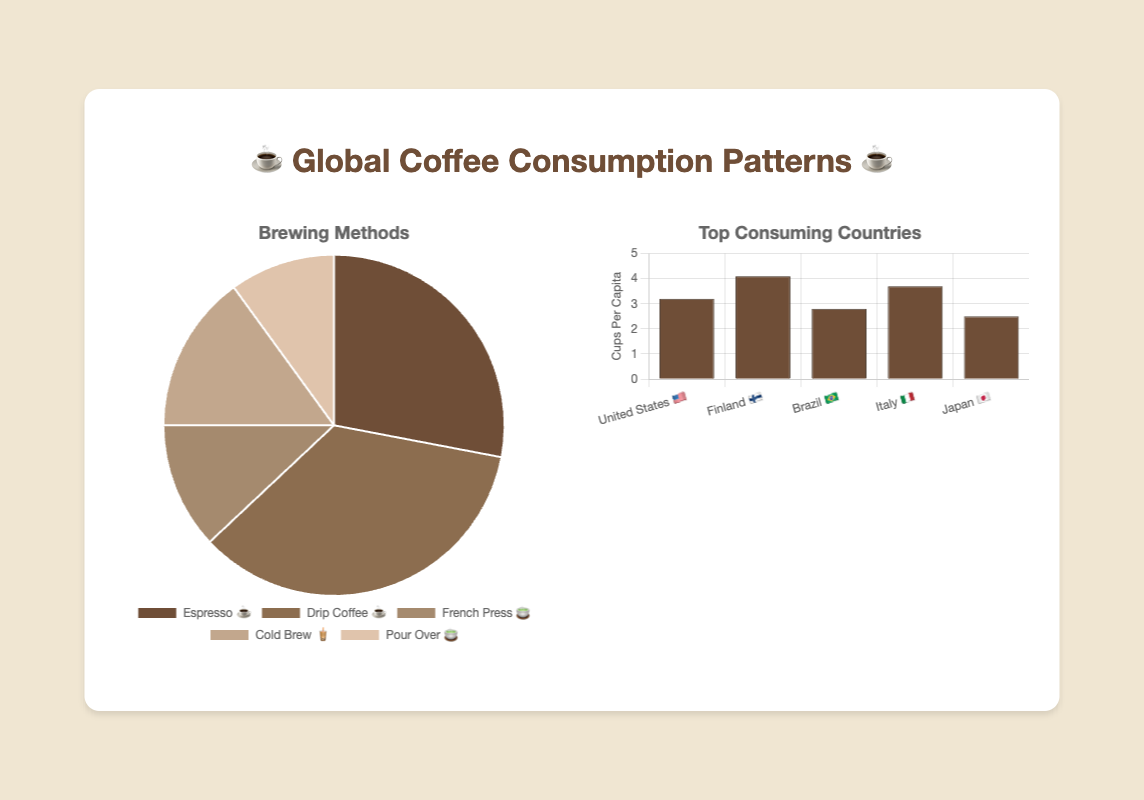What percentage of global coffee consumption is attributed to Drip Coffee ☕? The pie chart shows that Drip Coffee ☕ has a percentage listed within the chart segments. By looking at the label for Drip Coffee ☕, we see it reads 35%
Answer: 35% Which brewing method has the smallest percentage of global coffee consumption? By observing the pie chart, we can compare the listed percentages for each brewing method. The smallest segment by visual size is the one labeled "Pour Over 🍵" with a percentage of 10%
Answer: Pour Over 🍵 How many cups per capita does Italy 🇮🇹 consume, according to the bar chart? The bar chart on the right shows the countries on the x-axis and the corresponding cups per capita on the y-axis. For Italy 🇮🇹, the bar height corresponds to 3.7 cups per capita
Answer: 3.7 Which country has the highest cups per capita consumption? By comparing the heights of the bars in the chart, we see that Finland 🇫🇮 has the highest bar, which corresponds to 4.1 cups per capita
Answer: Finland 🇫🇮 What's the total percentage of global coffee consumption for French Press 🍵 and Cold Brew 🧋 methods combined? The pie chart lists percentages for each brewing method. Adding the percentages for French Press 🍵 (12%) and Cold Brew 🧋 (15%) gives a combined total of 12 + 15 = 27%
Answer: 27% Compare the coffee consumption per capita between the United States 🇺🇸 and Japan 🇯🇵. Which country consumes more and by how much more? The bar chart shows the cups per capita for the United States 🇺🇸 at 3.2 and Japan 🇯🇵 at 2.5. The difference is 3.2 - 2.5 = 0.7 cups. Therefore, the United States 🇺🇸 consumes 0.7 cups more per capita than Japan 🇯🇵
Answer: United States 🇺🇸 by 0.7 cups What is the average number of cups per capita consumed by the top five consuming countries? The bar chart lists values for each country: United States 🇺🇸 (3.2), Finland 🇫🇮 (4.1), Brazil 🇧🇷 (2.8), Italy 🇮🇹 (3.7), Japan 🇯🇵 (2.5). Summing these values and dividing by 5, (3.2 + 4.1 + 2.8 + 3.7 + 2.5)/5 = 3.26 cups
Answer: 3.26 Which brewing method has 3% more global consumption than Espresso ☕? The pie chart shows Espresso ☕ at 28%. Looking for a method that has 28% + 3% = 31%, we find that no method is exactly 31%, but Drip Coffee ☕ is closest at 35%
Answer: None 